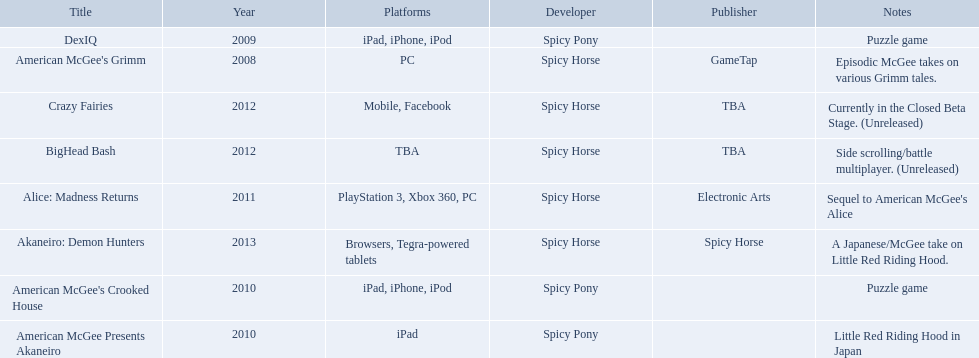Which spicy horse titles are shown? American McGee's Grimm, DexIQ, American McGee Presents Akaneiro, American McGee's Crooked House, Alice: Madness Returns, BigHead Bash, Crazy Fairies, Akaneiro: Demon Hunters. Of those, which are for the ipad? DexIQ, American McGee Presents Akaneiro, American McGee's Crooked House. Which of those are not for the iphone or ipod? American McGee Presents Akaneiro. 